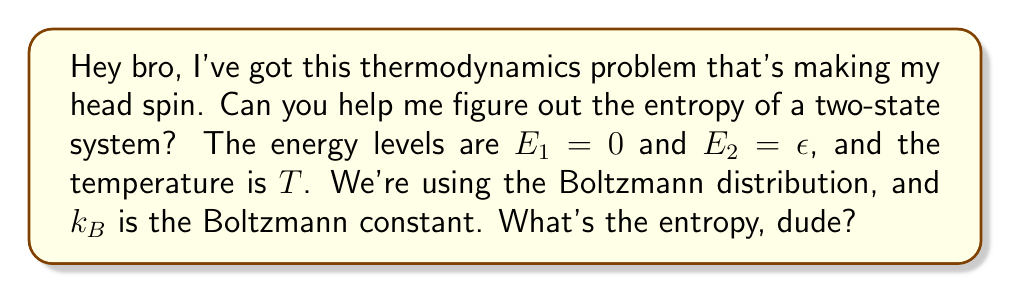Could you help me with this problem? Alright, let's break this down step-by-step:

1) The Boltzmann distribution gives us the probability of each state:
   $$p_i = \frac{e^{-E_i/k_BT}}{Z}$$
   where $Z$ is the partition function.

2) Calculate the partition function:
   $$Z = e^{-E_1/k_BT} + e^{-E_2/k_BT} = 1 + e^{-\epsilon/k_BT}$$

3) Now we can find the probabilities:
   $$p_1 = \frac{1}{1 + e^{-\epsilon/k_BT}}$$
   $$p_2 = \frac{e^{-\epsilon/k_BT}}{1 + e^{-\epsilon/k_BT}}$$

4) The entropy is given by:
   $$S = -k_B\sum_i p_i \ln p_i$$

5) Substituting our probabilities:
   $$S = -k_B\left(\frac{1}{1 + e^{-\epsilon/k_BT}} \ln\frac{1}{1 + e^{-\epsilon/k_BT}} + \frac{e^{-\epsilon/k_BT}}{1 + e^{-\epsilon/k_BT}} \ln\frac{e^{-\epsilon/k_BT}}{1 + e^{-\epsilon/k_BT}}\right)$$

6) Simplify:
   $$S = k_B\ln(1 + e^{-\epsilon/k_BT}) + \frac{k_B\epsilon}{T}\frac{e^{-\epsilon/k_BT}}{1 + e^{-\epsilon/k_BT}}$$

This is our final expression for the entropy of the two-state system.
Answer: $$S = k_B\ln(1 + e^{-\epsilon/k_BT}) + \frac{k_B\epsilon}{T}\frac{e^{-\epsilon/k_BT}}{1 + e^{-\epsilon/k_BT}}$$ 